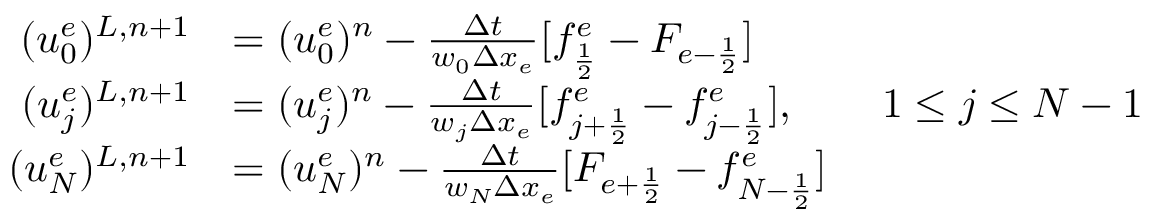<formula> <loc_0><loc_0><loc_500><loc_500>\begin{array} { r l } { ( u _ { 0 } ^ { e } ) ^ { L , n + 1 } } & { = ( u _ { 0 } ^ { e } ) ^ { n } - \frac { \Delta t } { w _ { 0 } \Delta x _ { e } } [ f _ { \frac { 1 } { 2 } } ^ { e } - F _ { e - \frac { 1 } { 2 } } ] } \\ { ( u _ { j } ^ { e } ) ^ { L , n + 1 } } & { = ( u _ { j } ^ { e } ) ^ { n } - \frac { \Delta t } { w _ { j } \Delta x _ { e } } [ f _ { j + \frac { 1 } { 2 } } ^ { e } - f _ { j - \frac { 1 } { 2 } } ^ { e } ] , \quad 1 \leq j \leq N - 1 } \\ { ( u _ { N } ^ { e } ) ^ { L , n + 1 } } & { = ( u _ { N } ^ { e } ) ^ { n } - \frac { \Delta t } { w _ { N } \Delta x _ { e } } [ F _ { e + \frac { 1 } { 2 } } - f _ { N - \frac { 1 } { 2 } } ^ { e } ] } \end{array}</formula> 